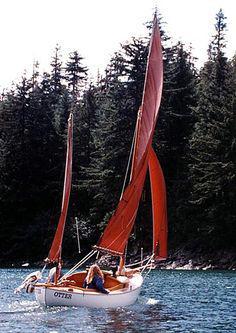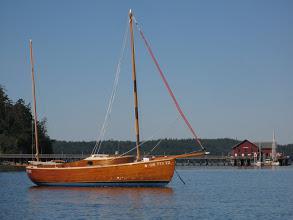The first image is the image on the left, the second image is the image on the right. Examine the images to the left and right. Is the description "There is a sailboat out in open water in the center of both images." accurate? Answer yes or no. Yes. The first image is the image on the left, the second image is the image on the right. Analyze the images presented: Is the assertion "In at least one image shows a boat with a visible name on its hull." valid? Answer yes or no. Yes. 